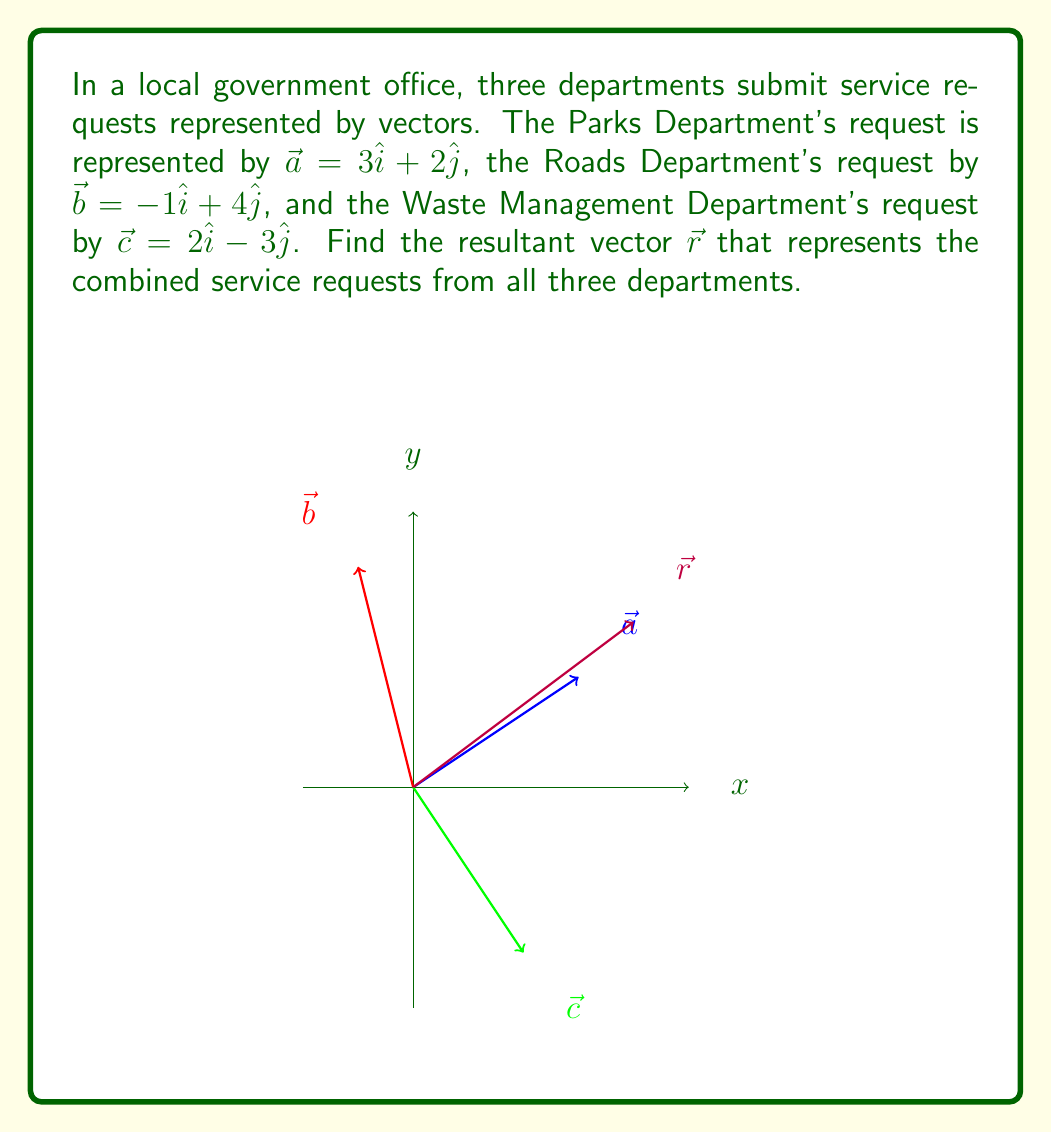Teach me how to tackle this problem. To find the resultant vector, we need to add all the component vectors:

$\vec{r} = \vec{a} + \vec{b} + \vec{c}$

Let's break this down step-by-step:

1) First, let's write out each vector in component form:
   $\vec{a} = 3\hat{i} + 2\hat{j}$
   $\vec{b} = -1\hat{i} + 4\hat{j}$
   $\vec{c} = 2\hat{i} - 3\hat{j}$

2) Now, we add these vectors by adding their corresponding components:

   $\vec{r} = (3\hat{i} + 2\hat{j}) + (-1\hat{i} + 4\hat{j}) + (2\hat{i} - 3\hat{j})$

3) Grouping like terms:

   $\vec{r} = (3 - 1 + 2)\hat{i} + (2 + 4 - 3)\hat{j}$

4) Simplifying:

   $\vec{r} = 4\hat{i} + 3\hat{j}$

This resultant vector represents the combined service requests from all three departments.
Answer: $\vec{r} = 4\hat{i} + 3\hat{j}$ 